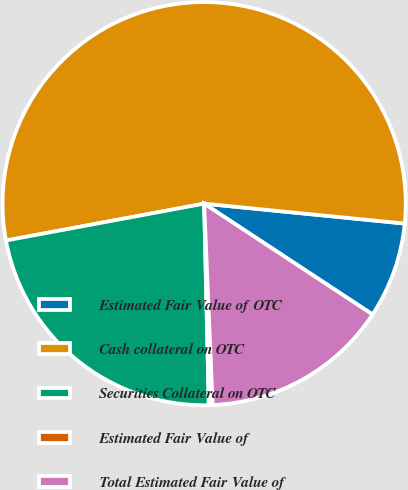Convert chart. <chart><loc_0><loc_0><loc_500><loc_500><pie_chart><fcel>Estimated Fair Value of OTC<fcel>Cash collateral on OTC<fcel>Securities Collateral on OTC<fcel>Estimated Fair Value of<fcel>Total Estimated Fair Value of<nl><fcel>7.69%<fcel>54.5%<fcel>22.44%<fcel>0.31%<fcel>15.06%<nl></chart> 